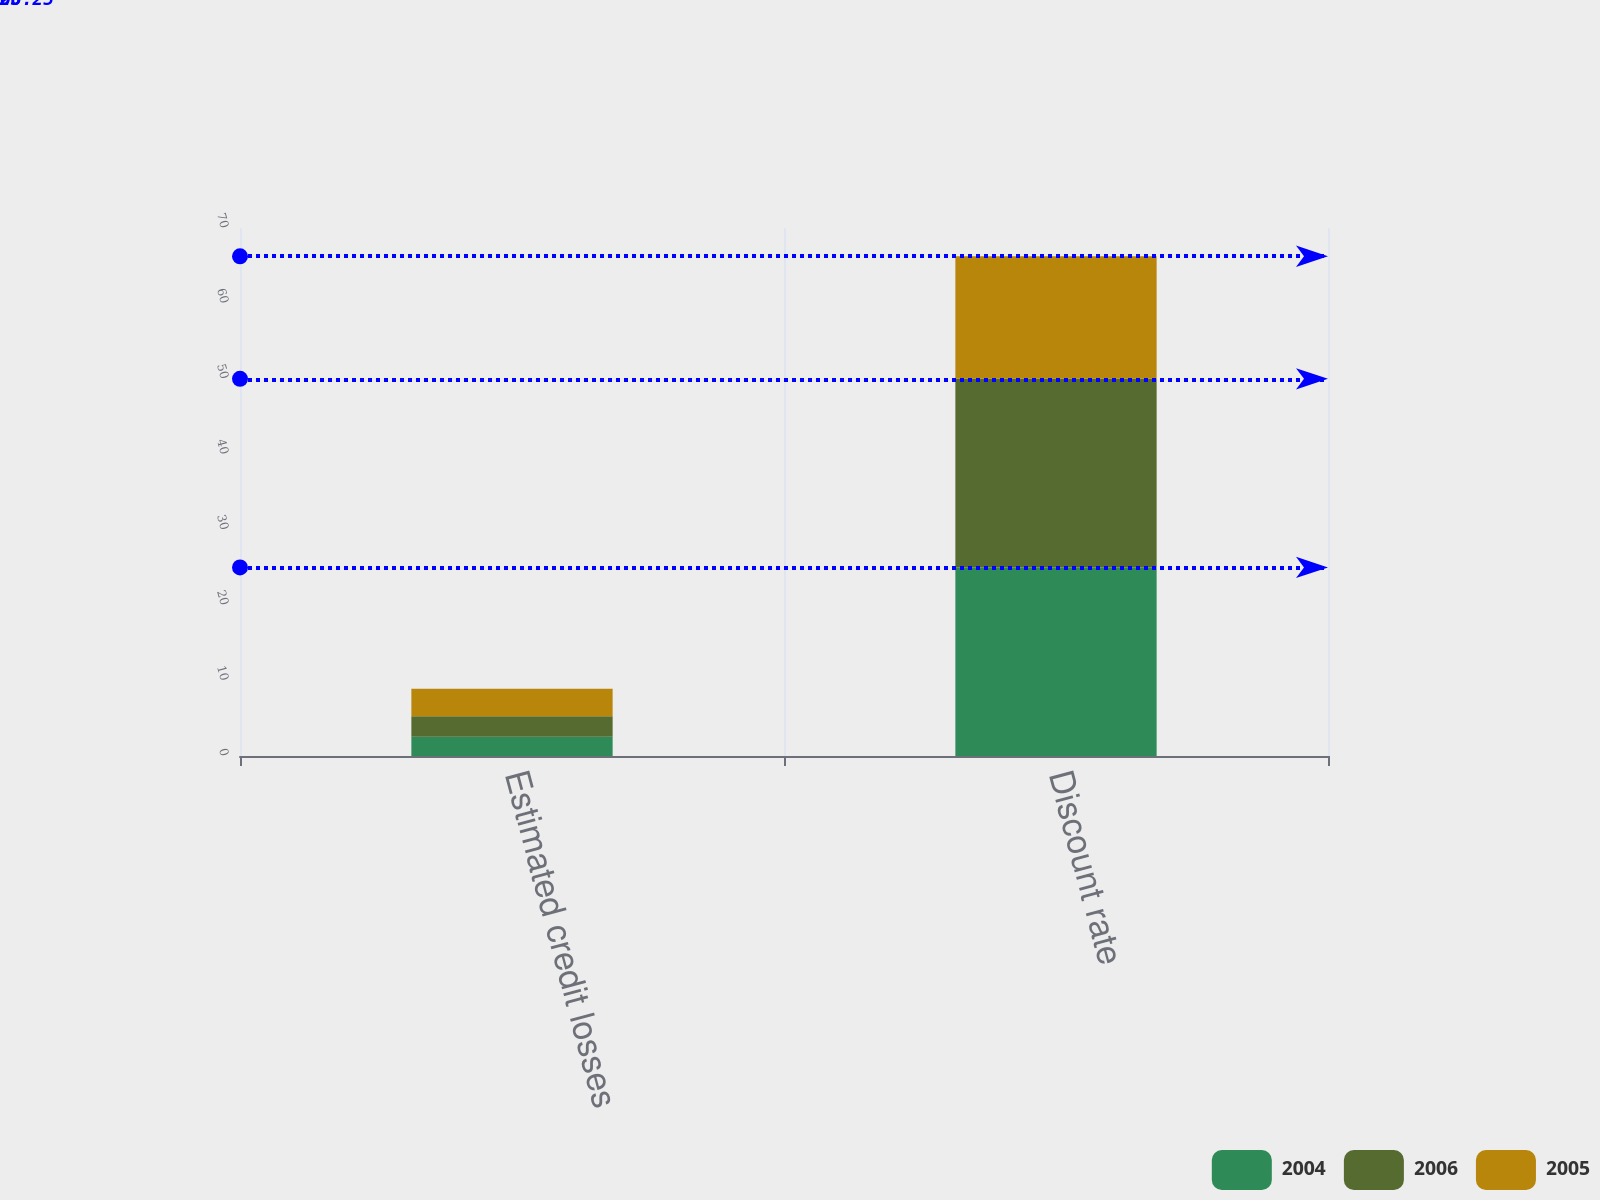<chart> <loc_0><loc_0><loc_500><loc_500><stacked_bar_chart><ecel><fcel>Estimated credit losses<fcel>Discount rate<nl><fcel>2004<fcel>2.55<fcel>25<nl><fcel>2006<fcel>2.72<fcel>25<nl><fcel>2005<fcel>3.63<fcel>16.25<nl></chart> 